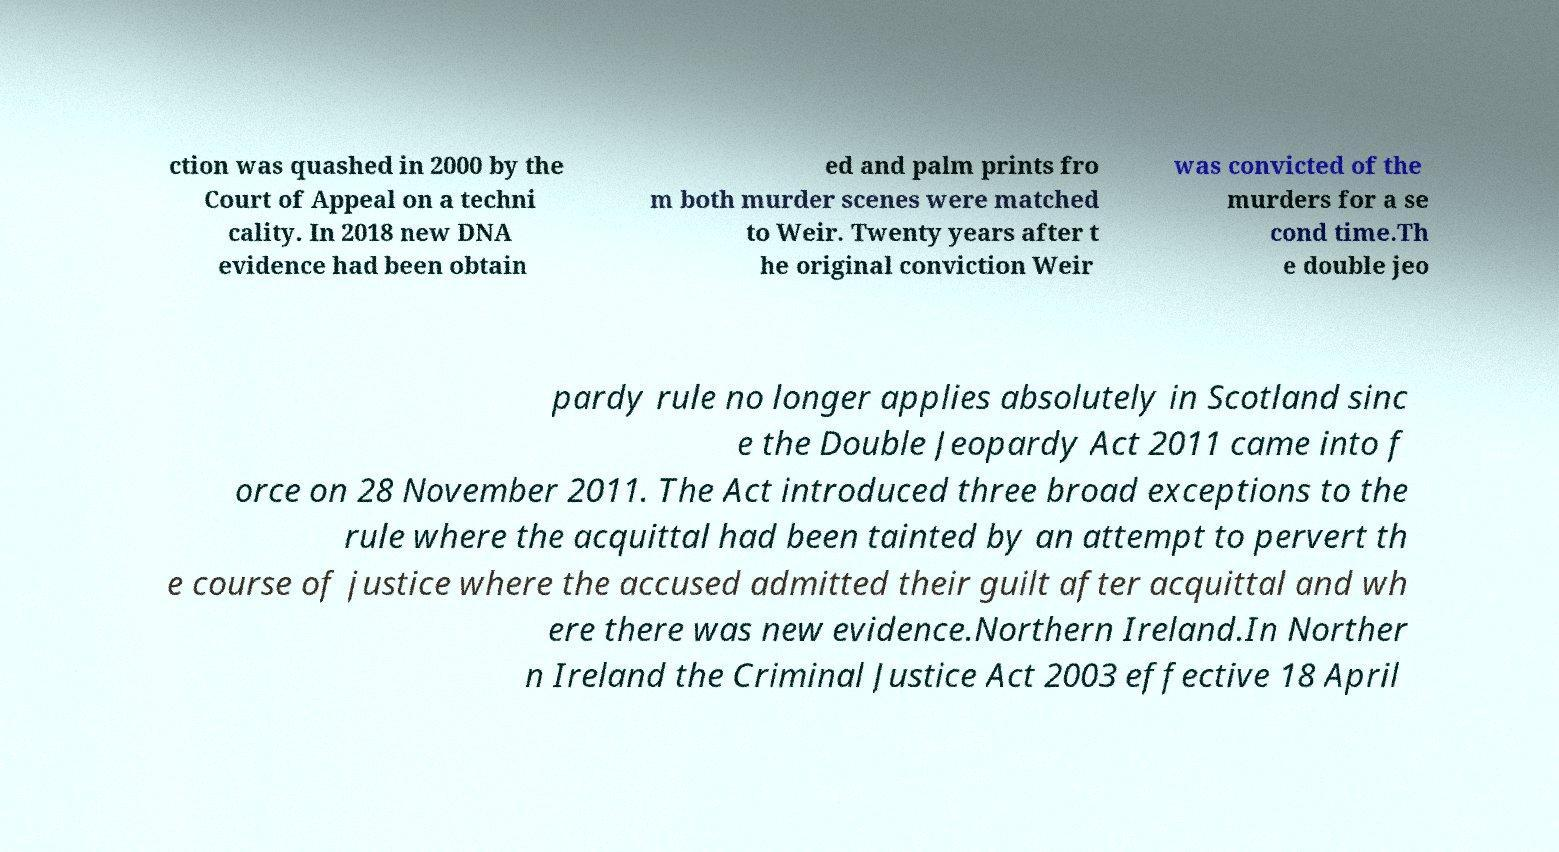Can you read and provide the text displayed in the image?This photo seems to have some interesting text. Can you extract and type it out for me? ction was quashed in 2000 by the Court of Appeal on a techni cality. In 2018 new DNA evidence had been obtain ed and palm prints fro m both murder scenes were matched to Weir. Twenty years after t he original conviction Weir was convicted of the murders for a se cond time.Th e double jeo pardy rule no longer applies absolutely in Scotland sinc e the Double Jeopardy Act 2011 came into f orce on 28 November 2011. The Act introduced three broad exceptions to the rule where the acquittal had been tainted by an attempt to pervert th e course of justice where the accused admitted their guilt after acquittal and wh ere there was new evidence.Northern Ireland.In Norther n Ireland the Criminal Justice Act 2003 effective 18 April 